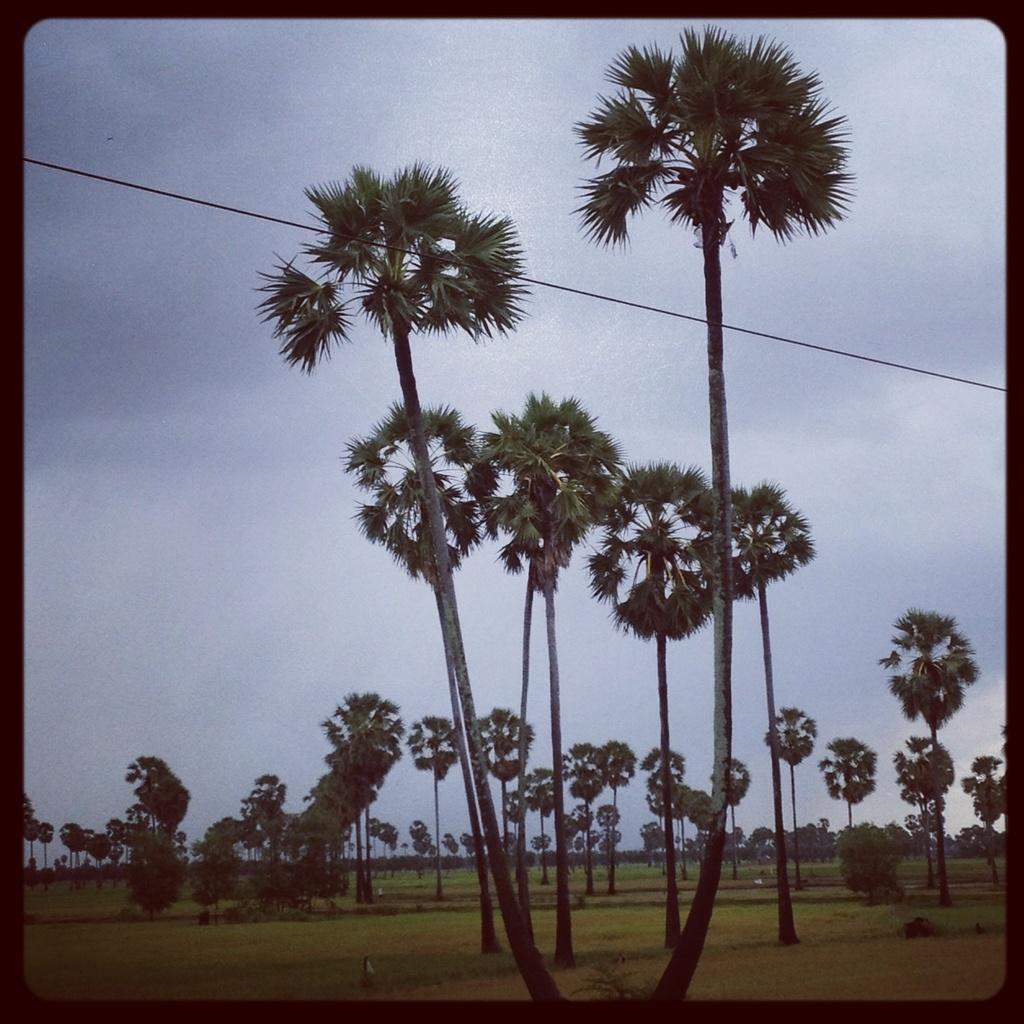What type of vegetation can be seen in the image? There are trees in the image. What is at the bottom of the image? There is grass at the bottom of the image. What can be seen in the background of the image? The sky is visible in the background of the image. Are there any weather-related features in the background? Yes, clouds are present in the background of the image. What type of badge can be seen hanging from the tree in the image? There is no badge present in the image; it only features trees, grass, and clouds. How much milk is visible in the image? There is no milk present in the image. 